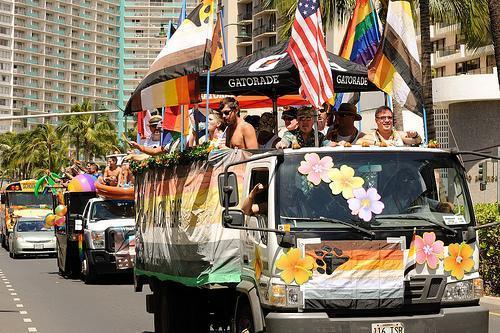How many trucks are there?
Give a very brief answer. 2. 